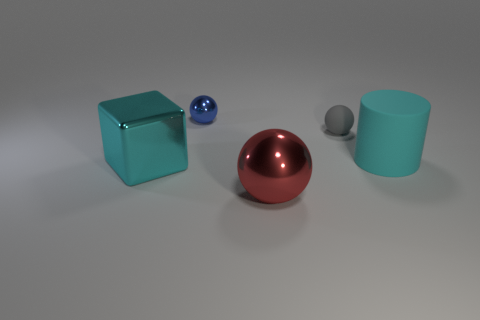The object that is the same color as the block is what shape?
Your answer should be very brief. Cylinder. What shape is the cyan object that is the same size as the cyan cube?
Ensure brevity in your answer.  Cylinder. The big thing to the left of the shiny thing that is behind the cyan object left of the small rubber thing is what shape?
Your answer should be very brief. Cube. Do the tiny rubber thing and the big thing right of the gray thing have the same shape?
Your response must be concise. No. What number of big objects are either matte things or matte spheres?
Your answer should be very brief. 1. Is there a metallic sphere of the same size as the cyan metal thing?
Give a very brief answer. Yes. What is the color of the metal ball behind the large cyan thing that is right of the large cyan thing left of the big matte cylinder?
Give a very brief answer. Blue. Do the block and the ball that is in front of the large cyan rubber cylinder have the same material?
Your answer should be very brief. Yes. What is the size of the red metal object that is the same shape as the gray matte object?
Offer a very short reply. Large. Are there the same number of big balls that are behind the big cyan cylinder and tiny gray rubber things that are behind the small rubber sphere?
Keep it short and to the point. Yes. 